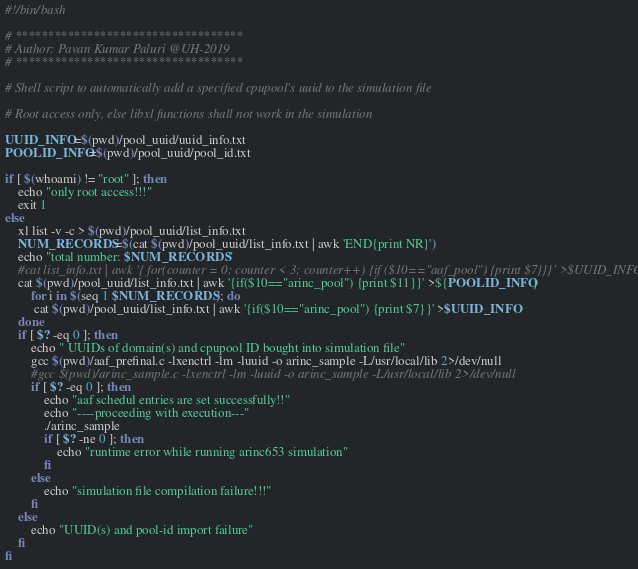<code> <loc_0><loc_0><loc_500><loc_500><_Bash_>#!/bin/bash

# ***********************************
# Author: Pavan Kumar Paluri @UH-2019
# ***********************************

# Shell script to automatically add a specified cpupool's uuid to the simulation file

# Root access only, else libxl functions shall not work in the simulation

UUID_INFO=$(pwd)/pool_uuid/uuid_info.txt
POOLID_INFO=$(pwd)/pool_uuid/pool_id.txt

if [ $(whoami) != "root" ]; then
	echo "only root access!!!"
	exit 1
else
	xl list -v -c > $(pwd)/pool_uuid/list_info.txt
	NUM_RECORDS=$(cat $(pwd)/pool_uuid/list_info.txt | awk 'END{print NR}')
	echo "total number: $NUM_RECORDS"
	#cat list_info.txt | awk '{ for(counter = 0; counter < 3; counter++) {if ($10=="aaf_pool") {print $7}}}' >$UUID_INFO
	cat $(pwd)/pool_uuid/list_info.txt | awk '{if($10=="arinc_pool") {print $11}}' >${POOLID_INFO}
        for i in $(seq 1 $NUM_RECORDS); do
		 cat $(pwd)/pool_uuid/list_info.txt | awk '{if($10=="arinc_pool") {print $7}}' >$UUID_INFO
	done
	if [ $? -eq 0 ]; then
		echo " UUIDs of domain(s) and cpupool ID bought into simulation file"
		gcc $(pwd)/aaf_prefinal.c -lxenctrl -lm -luuid -o arinc_sample -L/usr/local/lib 2>/dev/null
		#gcc $(pwd)/arinc_sample.c -lxenctrl -lm -luuid -o arinc_sample -L/usr/local/lib 2>/dev/null
		if [ $? -eq 0 ]; then
			echo "aaf schedul entries are set successfully!!"
			echo "----proceeding with execution---"
			./arinc_sample
			if [ $? -ne 0 ]; then
				echo "runtime error while running arinc653 simulation"
			fi
		else
			echo "simulation file compilation failure!!!"
		fi
	else
		echo "UUID(s) and pool-id import failure"
	fi
fi

</code> 